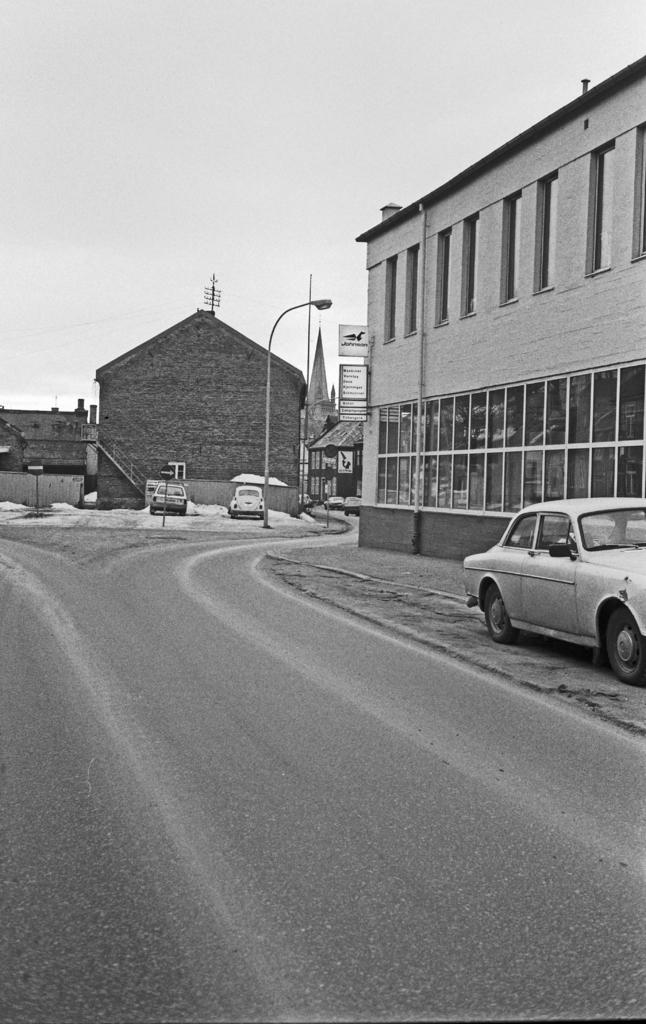What can be seen on the road in the image? There are vehicles on the road in the image. What is visible in the background of the image? There are buildings and light poles in the background of the image. What is the color scheme of the image? The image is in black and white. What else can be seen in the sky in the background of the image? The sky is visible in the background of the image. Can you tell me what type of soup is being served on the tray in the image? There is no soup or tray present in the image; it features vehicles on the road and buildings in the background. What is the position of the elbow in the image? There is no elbow visible in the image. 